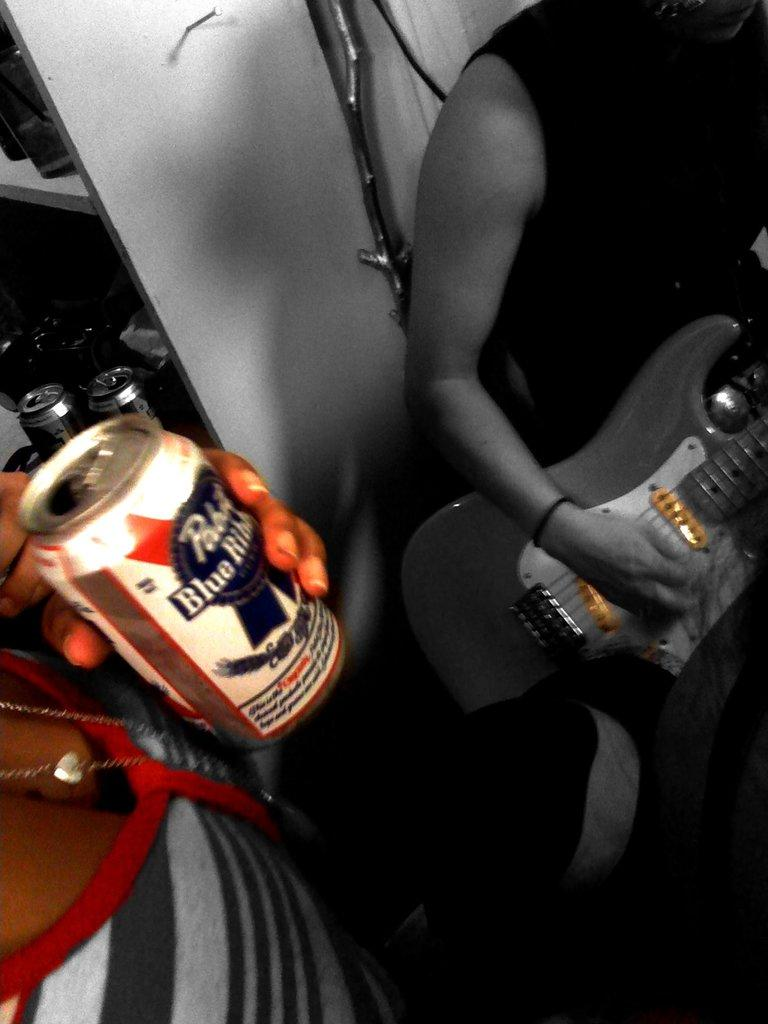What is the person on the left side of the image holding? The person on the left side of the image is holding a guitar. What is the person on the right side of the image holding? The person on the right side of the image is holding a tin. What type of advertisement can be seen on the guitar in the image? There is no advertisement present on the guitar in the image; it is simply a guitar being held by a person. 